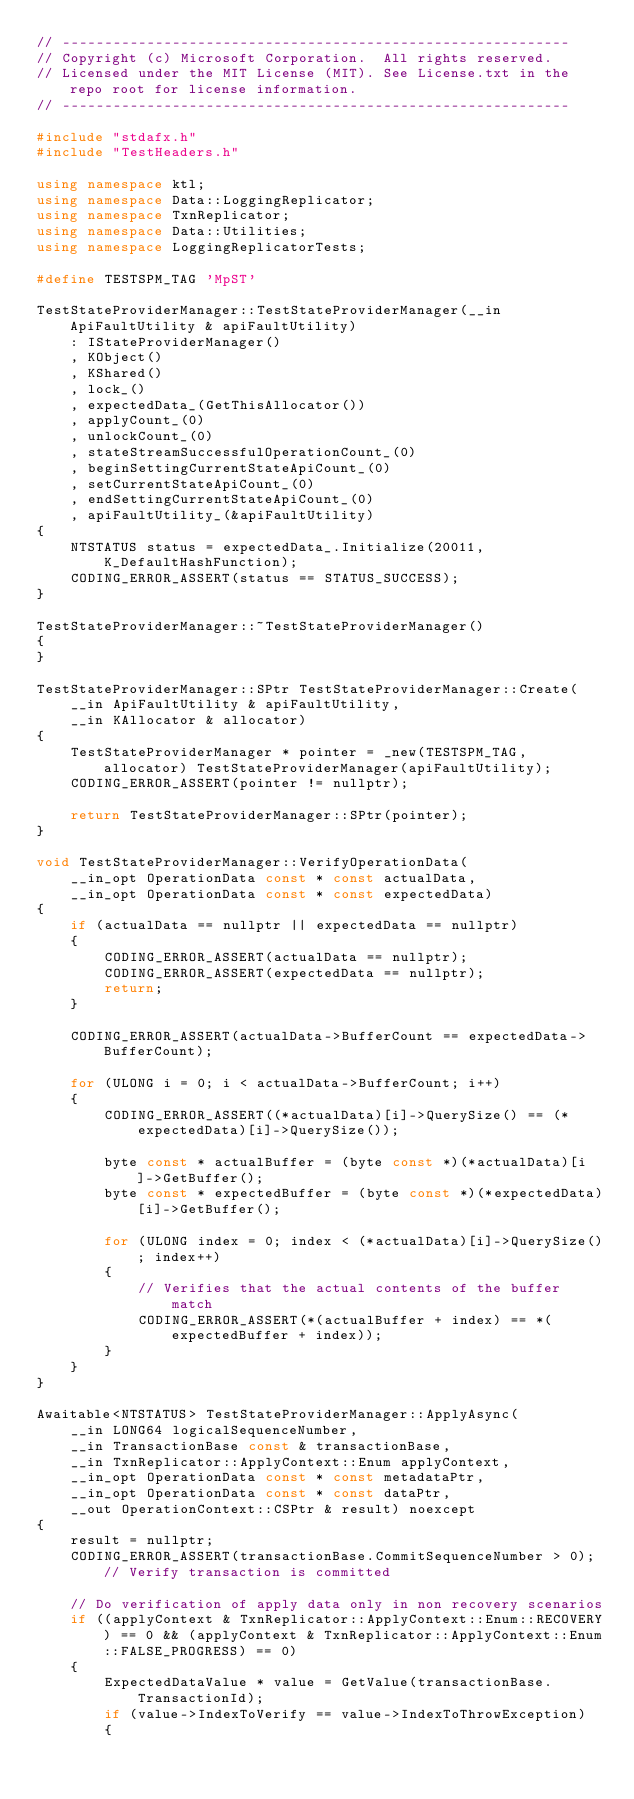<code> <loc_0><loc_0><loc_500><loc_500><_C++_>// ------------------------------------------------------------
// Copyright (c) Microsoft Corporation.  All rights reserved.
// Licensed under the MIT License (MIT). See License.txt in the repo root for license information.
// ------------------------------------------------------------

#include "stdafx.h"
#include "TestHeaders.h"

using namespace ktl;
using namespace Data::LoggingReplicator;
using namespace TxnReplicator;
using namespace Data::Utilities;
using namespace LoggingReplicatorTests;

#define TESTSPM_TAG 'MpST'

TestStateProviderManager::TestStateProviderManager(__in ApiFaultUtility & apiFaultUtility)
    : IStateProviderManager()
    , KObject()
    , KShared()
    , lock_()
    , expectedData_(GetThisAllocator())
    , applyCount_(0)
    , unlockCount_(0)
    , stateStreamSuccessfulOperationCount_(0)
    , beginSettingCurrentStateApiCount_(0)
    , setCurrentStateApiCount_(0)
    , endSettingCurrentStateApiCount_(0)
    , apiFaultUtility_(&apiFaultUtility)
{
    NTSTATUS status = expectedData_.Initialize(20011, K_DefaultHashFunction);
    CODING_ERROR_ASSERT(status == STATUS_SUCCESS);
}

TestStateProviderManager::~TestStateProviderManager()
{
}

TestStateProviderManager::SPtr TestStateProviderManager::Create(
    __in ApiFaultUtility & apiFaultUtility,
    __in KAllocator & allocator)
{
    TestStateProviderManager * pointer = _new(TESTSPM_TAG, allocator) TestStateProviderManager(apiFaultUtility);
    CODING_ERROR_ASSERT(pointer != nullptr);

    return TestStateProviderManager::SPtr(pointer);
}

void TestStateProviderManager::VerifyOperationData(
    __in_opt OperationData const * const actualData,
    __in_opt OperationData const * const expectedData)
{
    if (actualData == nullptr || expectedData == nullptr)
    {
        CODING_ERROR_ASSERT(actualData == nullptr);
        CODING_ERROR_ASSERT(expectedData == nullptr);
        return;
    }

    CODING_ERROR_ASSERT(actualData->BufferCount == expectedData->BufferCount);
    
    for (ULONG i = 0; i < actualData->BufferCount; i++)
    {
        CODING_ERROR_ASSERT((*actualData)[i]->QuerySize() == (*expectedData)[i]->QuerySize());

        byte const * actualBuffer = (byte const *)(*actualData)[i]->GetBuffer();
        byte const * expectedBuffer = (byte const *)(*expectedData)[i]->GetBuffer();
           
        for (ULONG index = 0; index < (*actualData)[i]->QuerySize(); index++)
        {
            // Verifies that the actual contents of the buffer match
            CODING_ERROR_ASSERT(*(actualBuffer + index) == *(expectedBuffer + index));
        }
    }
}

Awaitable<NTSTATUS> TestStateProviderManager::ApplyAsync(
    __in LONG64 logicalSequenceNumber,
    __in TransactionBase const & transactionBase,
    __in TxnReplicator::ApplyContext::Enum applyContext,
    __in_opt OperationData const * const metadataPtr,
    __in_opt OperationData const * const dataPtr,
    __out OperationContext::CSPtr & result) noexcept
{
    result = nullptr;
    CODING_ERROR_ASSERT(transactionBase.CommitSequenceNumber > 0); // Verify transaction is committed

    // Do verification of apply data only in non recovery scenarios
    if ((applyContext & TxnReplicator::ApplyContext::Enum::RECOVERY) == 0 && (applyContext & TxnReplicator::ApplyContext::Enum::FALSE_PROGRESS) == 0)
    {
        ExpectedDataValue * value = GetValue(transactionBase.TransactionId);
        if (value->IndexToVerify == value->IndexToThrowException)
        {</code> 